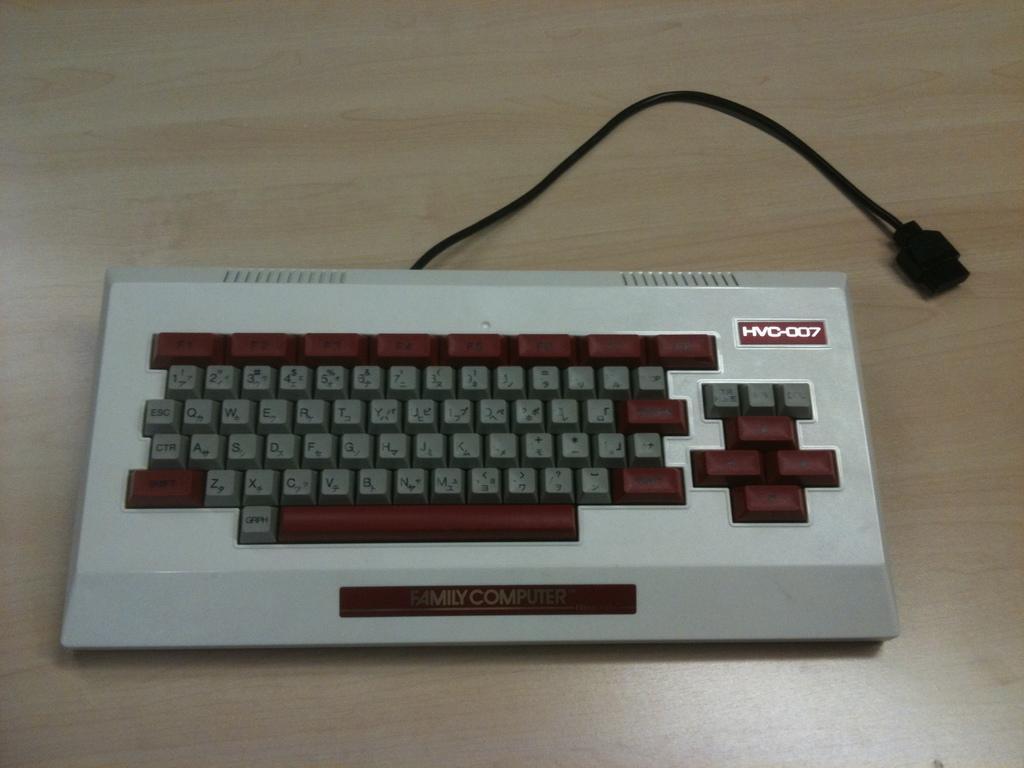How would you summarize this image in a sentence or two? In this picture we can see a keyboard and a wire, we can see some text on the keyboard, at the bottom there is a wooden surface. 